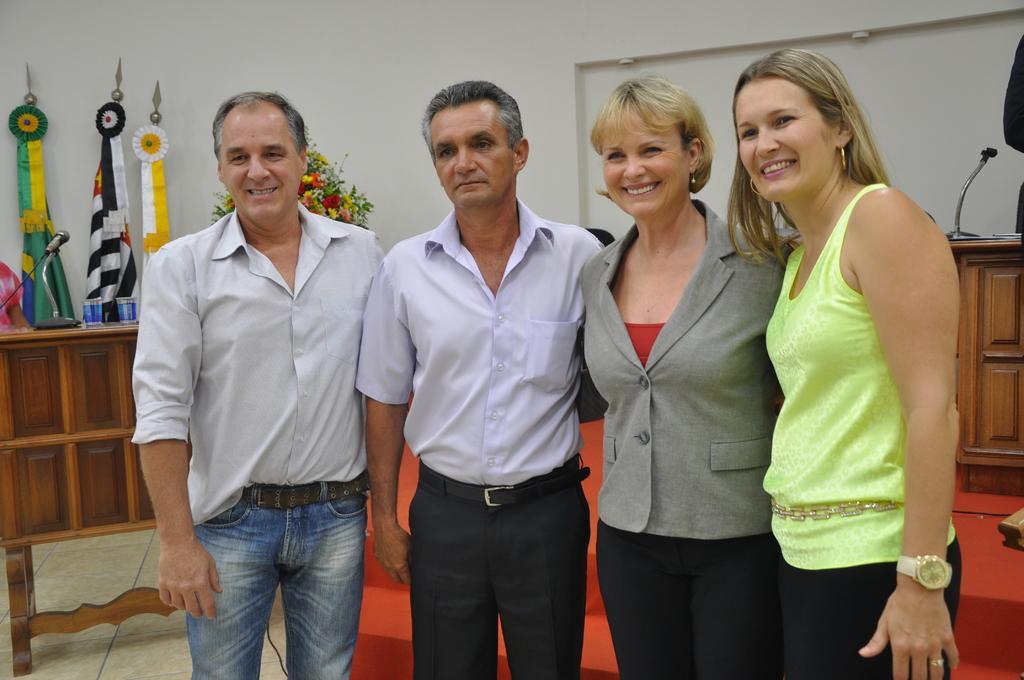Can you describe this image briefly? In the picture there are two men and two women present, behind there is a wall, there is a microphone present on the table, beside there is another table, there are glasses present, there are flags present, there is a flower bouquet present. 